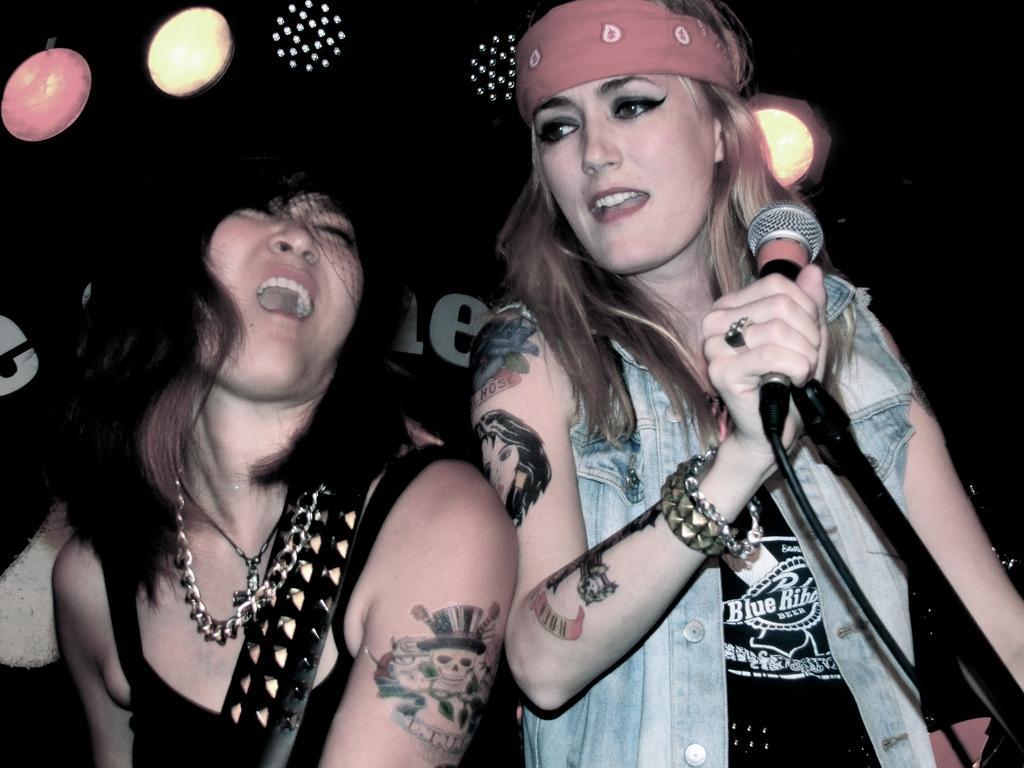Could you give a brief overview of what you see in this image? In this image, we can see two women are singing. Here a woman is holding a microphone. Here we can see tattoo on their bodies. On the right side of the image, we can see a rod. Background there is a dark view, lights and text. 